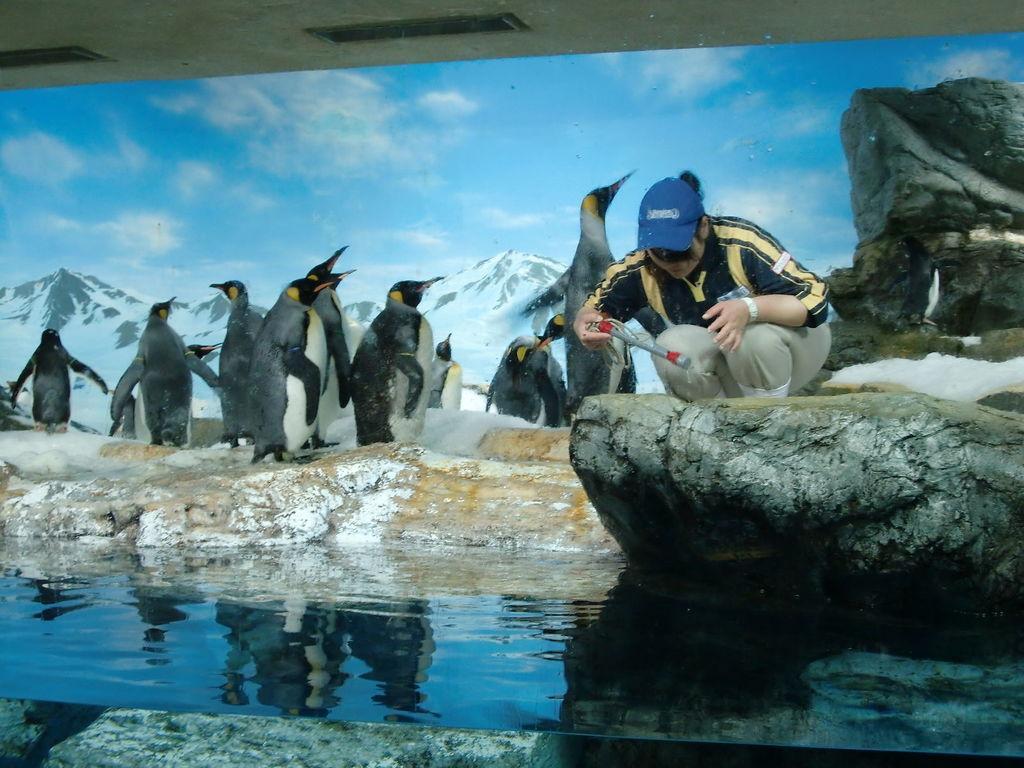Describe this image in one or two sentences. In this image in Center there is water and there is a woman standing on the stone and in the background there are penguins, mountains and the sky is cloudy. 